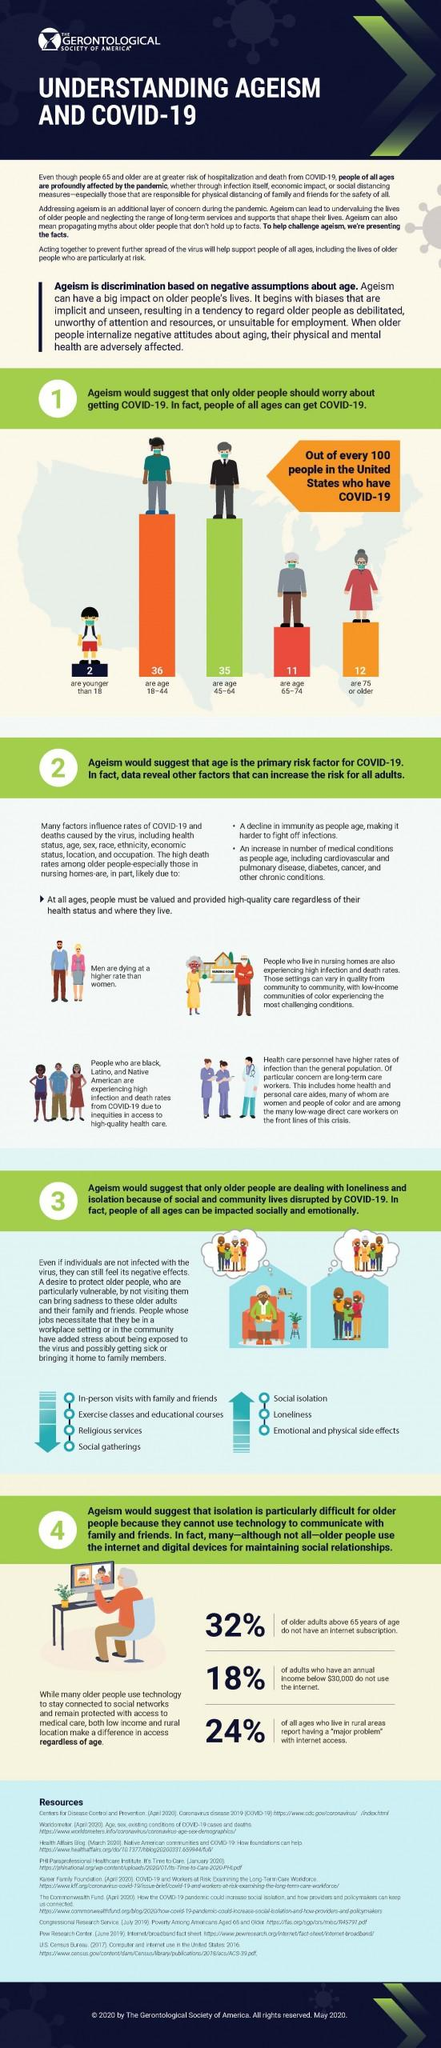Highlight a few significant elements in this photo. According to the data, 68% of adults aged 65 and older have an internet subscription. The age group with the highest number of COVID-19 cases in the United States is individuals aged 18-44. The age group with the lowest number of COVID-19 cases in the United States is younger than 18. 